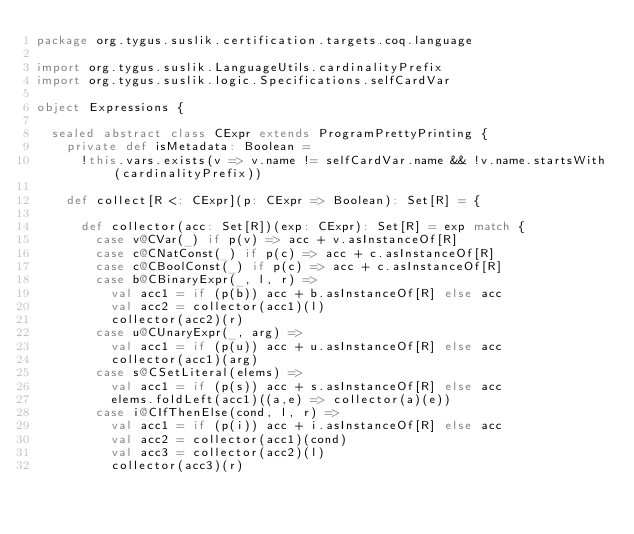Convert code to text. <code><loc_0><loc_0><loc_500><loc_500><_Scala_>package org.tygus.suslik.certification.targets.coq.language

import org.tygus.suslik.LanguageUtils.cardinalityPrefix
import org.tygus.suslik.logic.Specifications.selfCardVar

object Expressions {

  sealed abstract class CExpr extends ProgramPrettyPrinting {
    private def isMetadata: Boolean =
      !this.vars.exists(v => v.name != selfCardVar.name && !v.name.startsWith(cardinalityPrefix))

    def collect[R <: CExpr](p: CExpr => Boolean): Set[R] = {

      def collector(acc: Set[R])(exp: CExpr): Set[R] = exp match {
        case v@CVar(_) if p(v) => acc + v.asInstanceOf[R]
        case c@CNatConst(_) if p(c) => acc + c.asInstanceOf[R]
        case c@CBoolConst(_) if p(c) => acc + c.asInstanceOf[R]
        case b@CBinaryExpr(_, l, r) =>
          val acc1 = if (p(b)) acc + b.asInstanceOf[R] else acc
          val acc2 = collector(acc1)(l)
          collector(acc2)(r)
        case u@CUnaryExpr(_, arg) =>
          val acc1 = if (p(u)) acc + u.asInstanceOf[R] else acc
          collector(acc1)(arg)
        case s@CSetLiteral(elems) =>
          val acc1 = if (p(s)) acc + s.asInstanceOf[R] else acc
          elems.foldLeft(acc1)((a,e) => collector(a)(e))
        case i@CIfThenElse(cond, l, r) =>
          val acc1 = if (p(i)) acc + i.asInstanceOf[R] else acc
          val acc2 = collector(acc1)(cond)
          val acc3 = collector(acc2)(l)
          collector(acc3)(r)</code> 